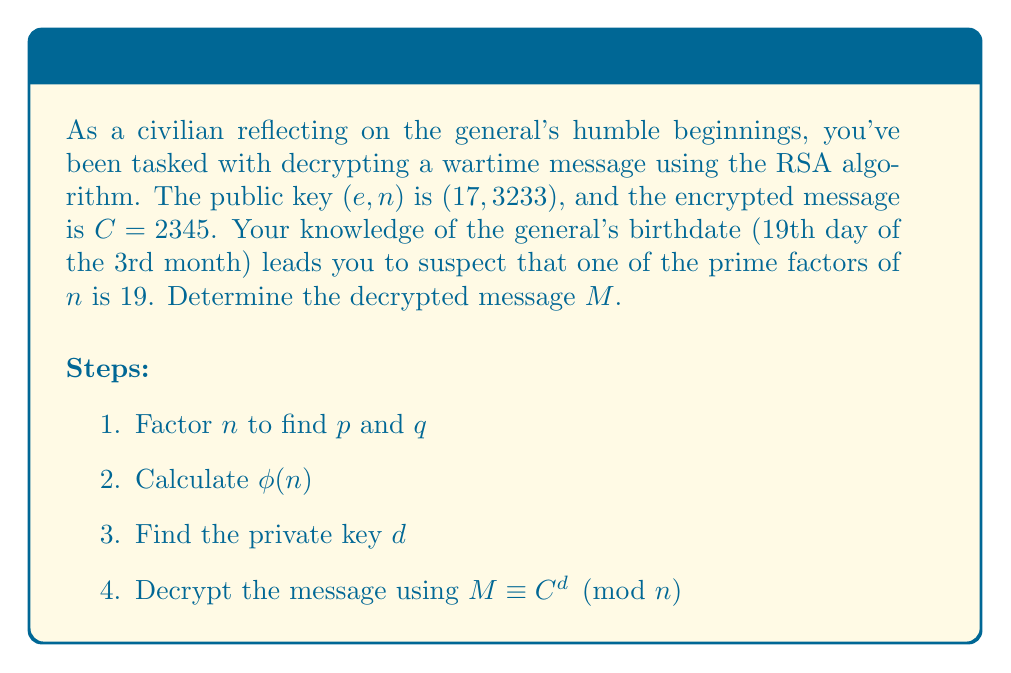Provide a solution to this math problem. 1. Factor $n$:
   Given that 19 is a factor, we can find the other factor:
   $3233 \div 19 = 170$
   So, $p = 19$ and $q = 170$

2. Calculate $\phi(n)$:
   $\phi(n) = (p-1)(q-1) = 18 \times 169 = 3042$

3. Find the private key $d$:
   We need to solve the congruence: $ed \equiv 1 \pmod{\phi(n)}$
   $17d \equiv 1 \pmod{3042}$
   Using the extended Euclidean algorithm or modular inverse:
   $d = 1785$

4. Decrypt the message:
   $M \equiv C^d \pmod{n}$
   $M \equiv 2345^{1785} \pmod{3233}$

   To compute this efficiently, we can use the square-and-multiply algorithm:
   
   $2345^{1785} \equiv 1941 \pmod{3233}$

Therefore, the decrypted message is 1941.
Answer: 1941 